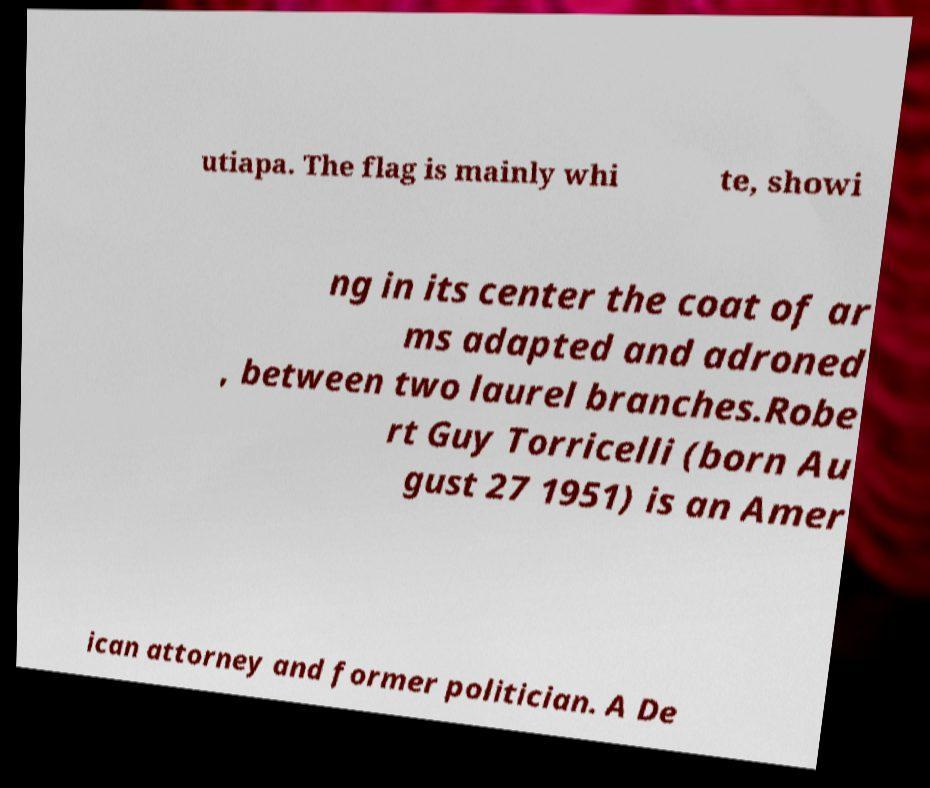Please identify and transcribe the text found in this image. utiapa. The flag is mainly whi te, showi ng in its center the coat of ar ms adapted and adroned , between two laurel branches.Robe rt Guy Torricelli (born Au gust 27 1951) is an Amer ican attorney and former politician. A De 